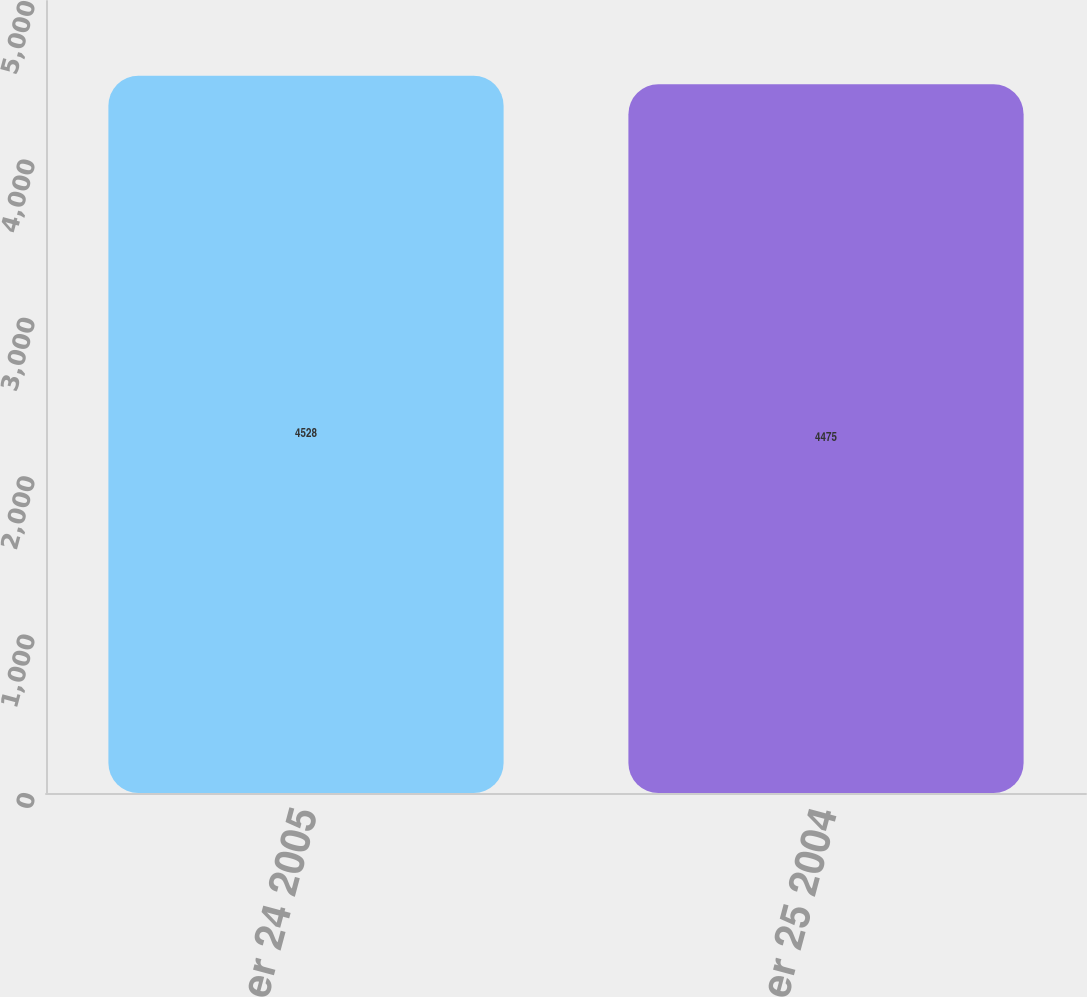<chart> <loc_0><loc_0><loc_500><loc_500><bar_chart><fcel>September 24 2005<fcel>September 25 2004<nl><fcel>4528<fcel>4475<nl></chart> 